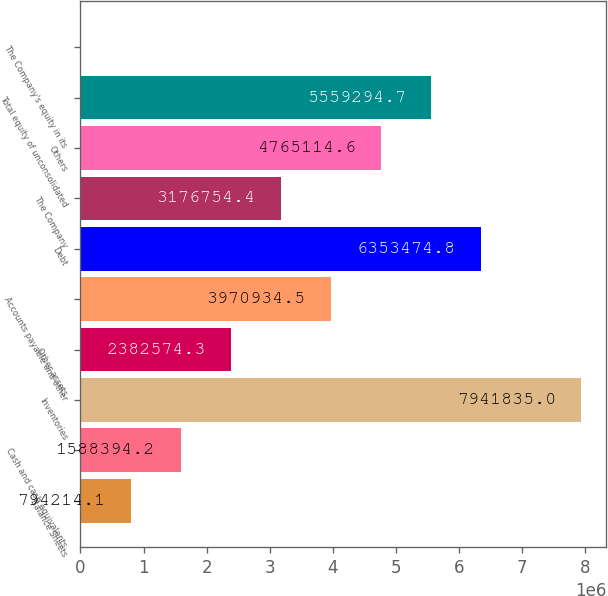Convert chart to OTSL. <chart><loc_0><loc_0><loc_500><loc_500><bar_chart><fcel>Balance Sheets<fcel>Cash and cash equivalents<fcel>Inventories<fcel>Other assets<fcel>Accounts payable and other<fcel>Debt<fcel>The Company<fcel>Others<fcel>Total equity of unconsolidated<fcel>The Company's equity in its<nl><fcel>794214<fcel>1.58839e+06<fcel>7.94184e+06<fcel>2.38257e+06<fcel>3.97093e+06<fcel>6.35347e+06<fcel>3.17675e+06<fcel>4.76511e+06<fcel>5.55929e+06<fcel>34<nl></chart> 